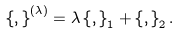<formula> <loc_0><loc_0><loc_500><loc_500>\left \{ , \right \} ^ { \left ( \lambda \right ) } = \lambda \left \{ , \right \} _ { 1 } + \left \{ , \right \} _ { 2 } .</formula> 